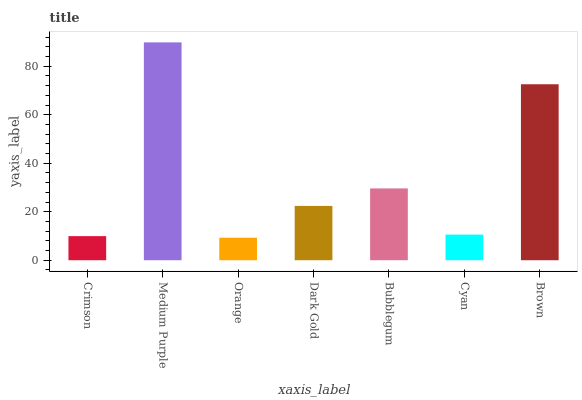Is Medium Purple the minimum?
Answer yes or no. No. Is Orange the maximum?
Answer yes or no. No. Is Medium Purple greater than Orange?
Answer yes or no. Yes. Is Orange less than Medium Purple?
Answer yes or no. Yes. Is Orange greater than Medium Purple?
Answer yes or no. No. Is Medium Purple less than Orange?
Answer yes or no. No. Is Dark Gold the high median?
Answer yes or no. Yes. Is Dark Gold the low median?
Answer yes or no. Yes. Is Orange the high median?
Answer yes or no. No. Is Orange the low median?
Answer yes or no. No. 